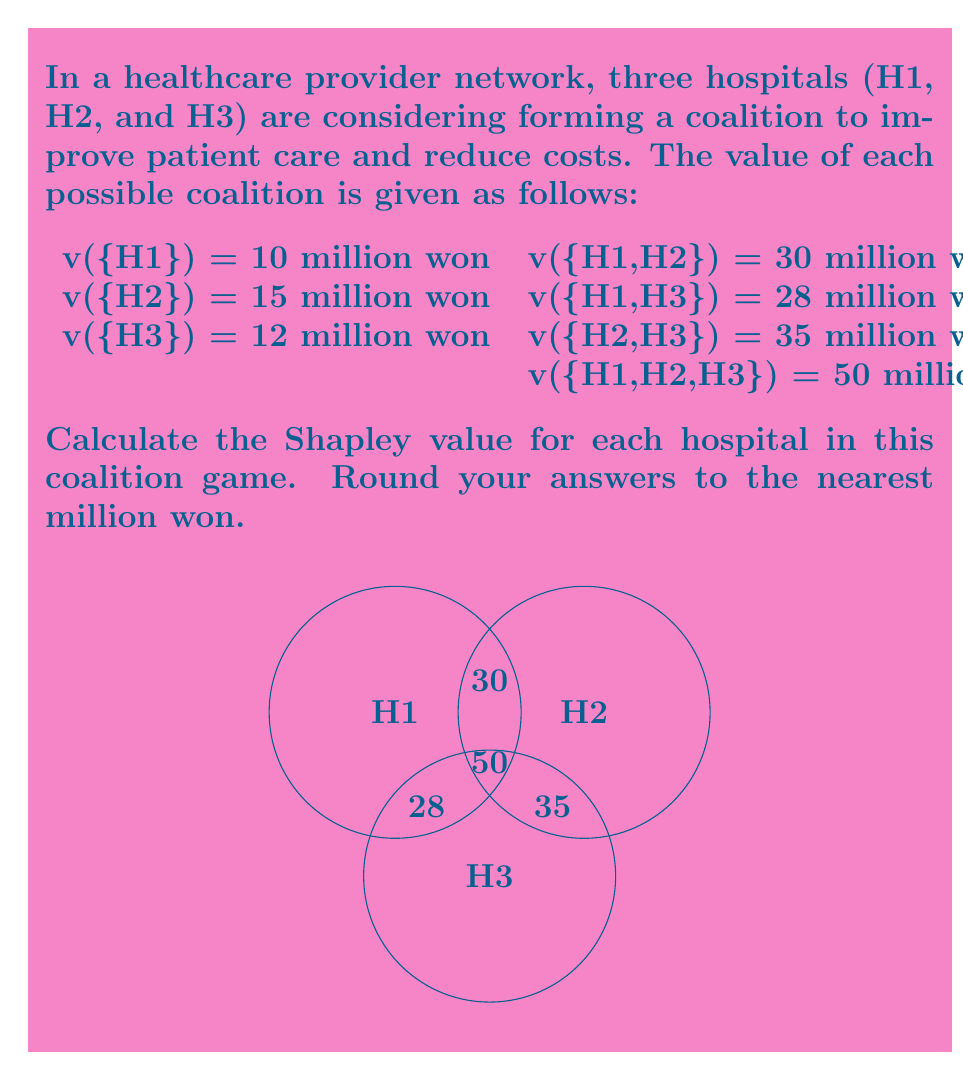Could you help me with this problem? To calculate the Shapley value, we need to determine each player's marginal contribution in all possible coalition formations and then take the average. The formula for the Shapley value is:

$$ \phi_i(v) = \sum_{S \subseteq N \setminus \{i\}} \frac{|S|!(n-|S|-1)!}{n!}[v(S \cup \{i\}) - v(S)] $$

Where $n$ is the number of players, $S$ is a subset of players excluding player $i$, and $v$ is the characteristic function.

Let's calculate for each hospital:

1. For H1:
   a) {} → {H1}: 10 - 0 = 10
   b) {H2} → {H1,H2}: 30 - 15 = 15
   c) {H3} → {H1,H3}: 28 - 12 = 16
   d) {H2,H3} → {H1,H2,H3}: 50 - 35 = 15

   $\phi_{H1} = \frac{1}{3}(10) + \frac{1}{6}(15 + 16 + 15) = 3.33 + 7.67 = 15$

2. For H2:
   a) {} → {H2}: 15 - 0 = 15
   b) {H1} → {H1,H2}: 30 - 10 = 20
   c) {H3} → {H2,H3}: 35 - 12 = 23
   d) {H1,H3} → {H1,H2,H3}: 50 - 28 = 22

   $\phi_{H2} = \frac{1}{3}(15) + \frac{1}{6}(20 + 23 + 22) = 5 + 10.83 = 15.83$

3. For H3:
   a) {} → {H3}: 12 - 0 = 12
   b) {H1} → {H1,H3}: 28 - 10 = 18
   c) {H2} → {H2,H3}: 35 - 15 = 20
   d) {H1,H2} → {H1,H2,H3}: 50 - 30 = 20

   $\phi_{H3} = \frac{1}{3}(12) + \frac{1}{6}(18 + 20 + 20) = 4 + 9.67 = 13.67$

Rounding to the nearest million won:
H1: 15 million won
H2: 16 million won
H3: 14 million won
Answer: H1: 15 million won, H2: 16 million won, H3: 14 million won 